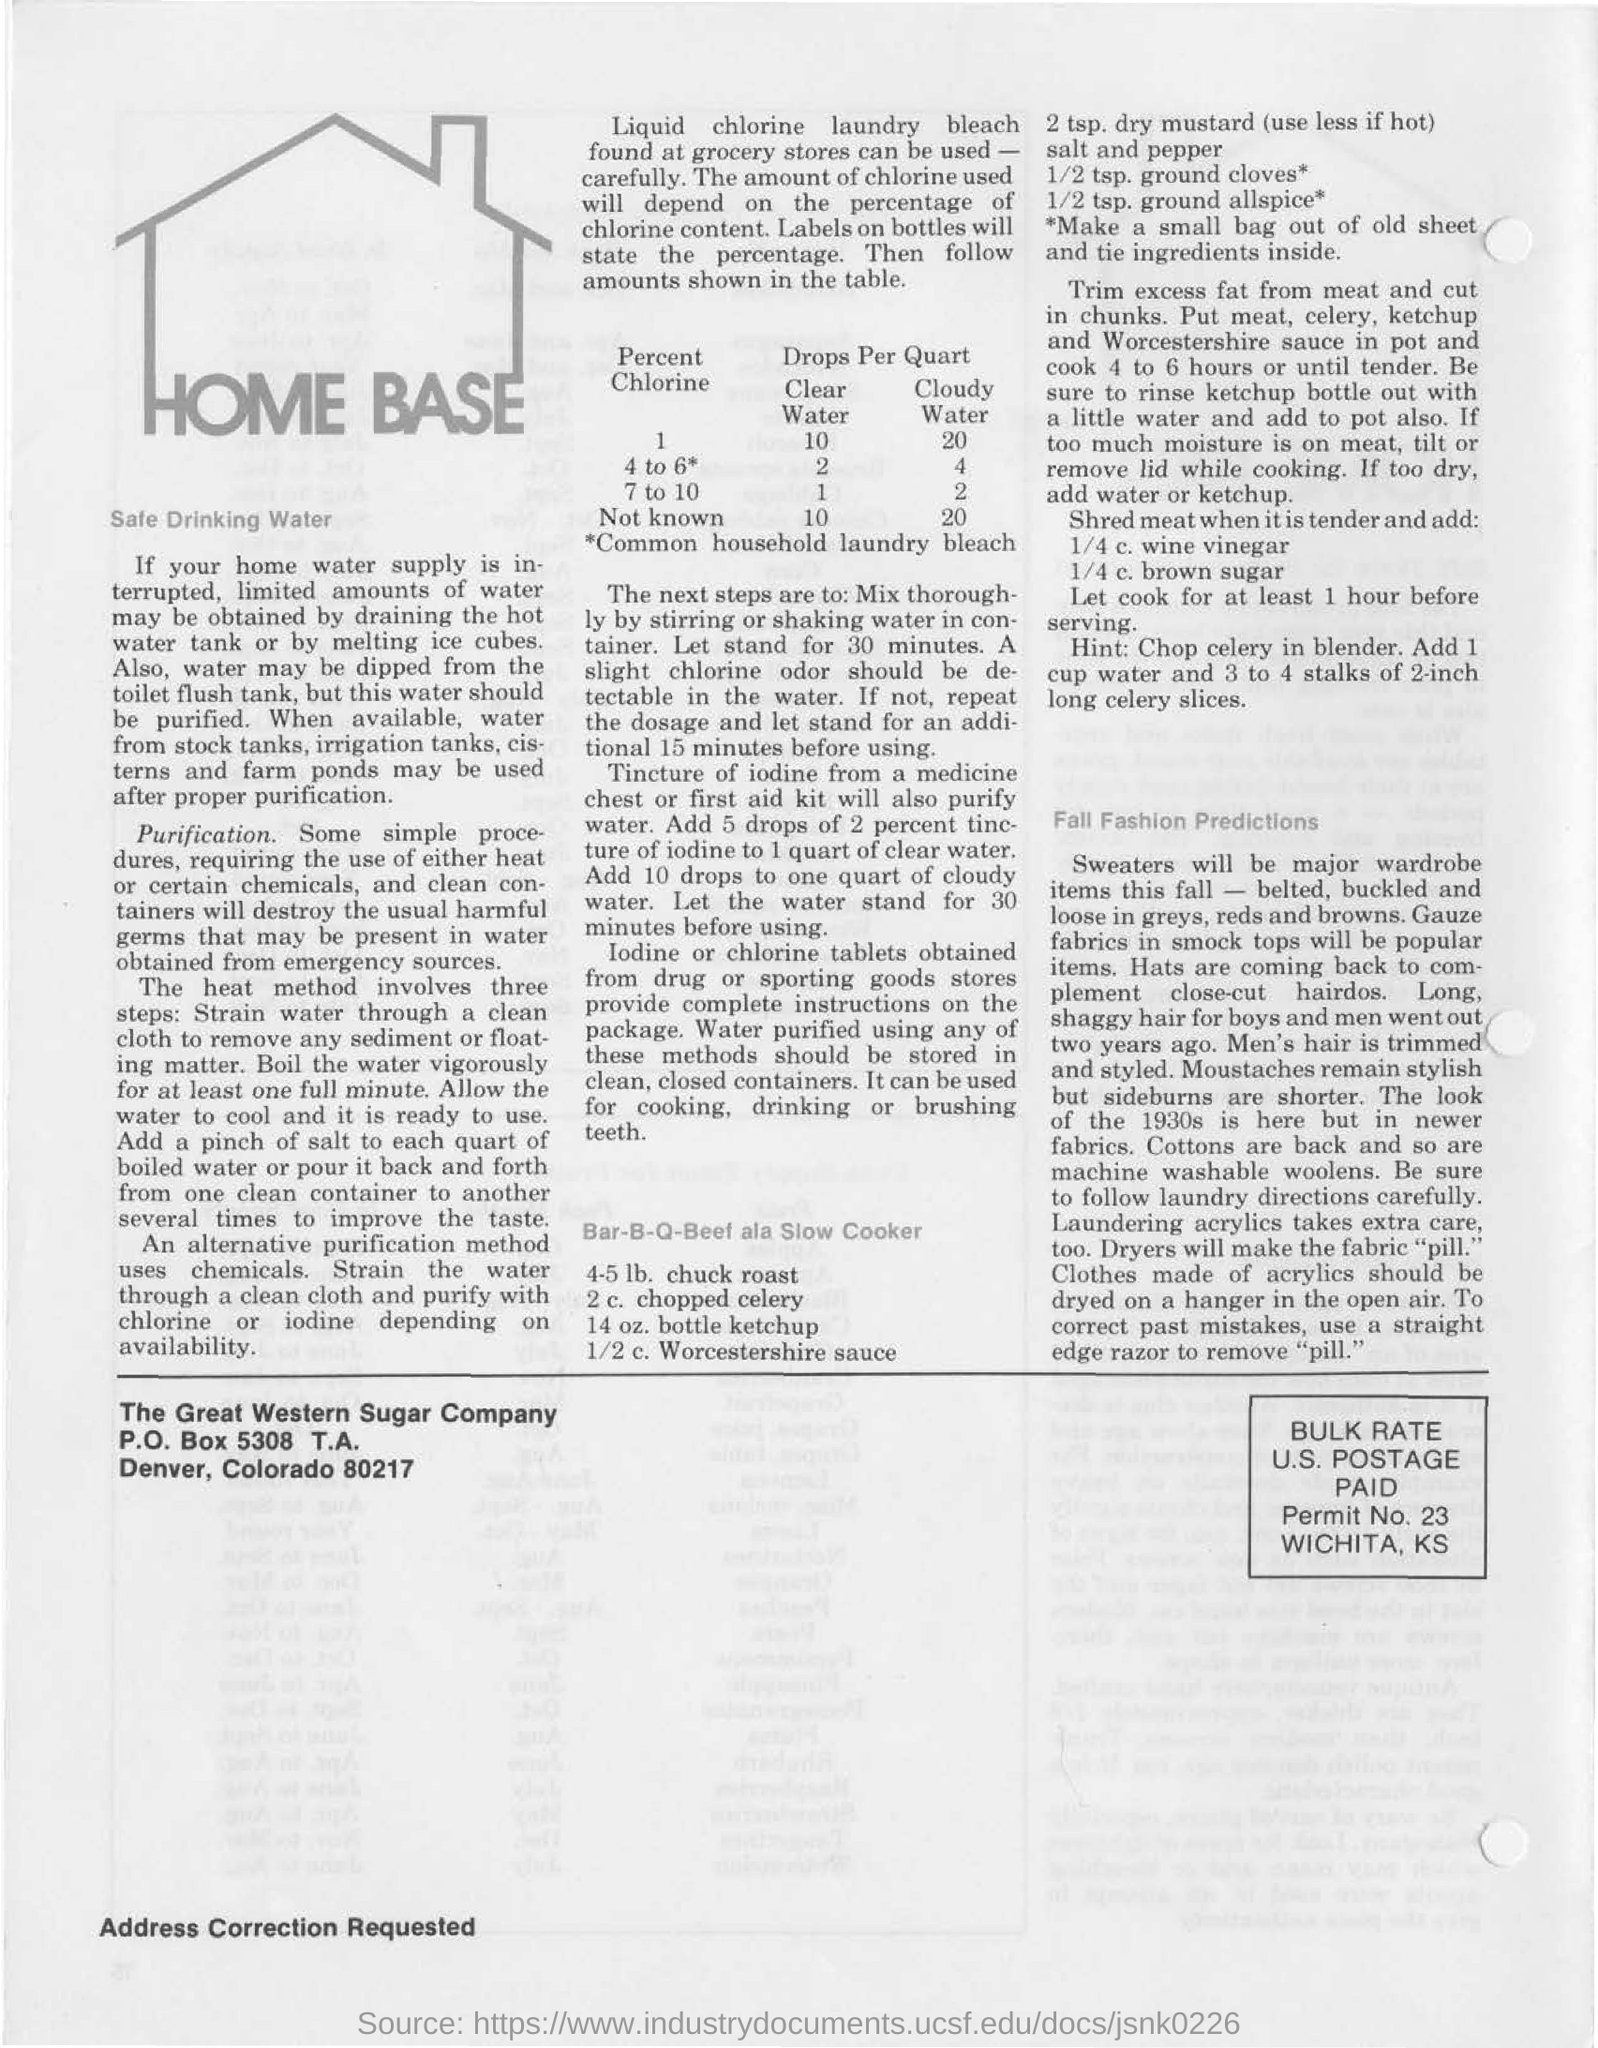Highlight a few significant elements in this photo. The P.O.Box of The Great Western Sugar Company is 5308. In the event of a disruption in the home water supply, it is recommended to obtain water from the hot water tank or by melting ice cubes as an alternative source. 